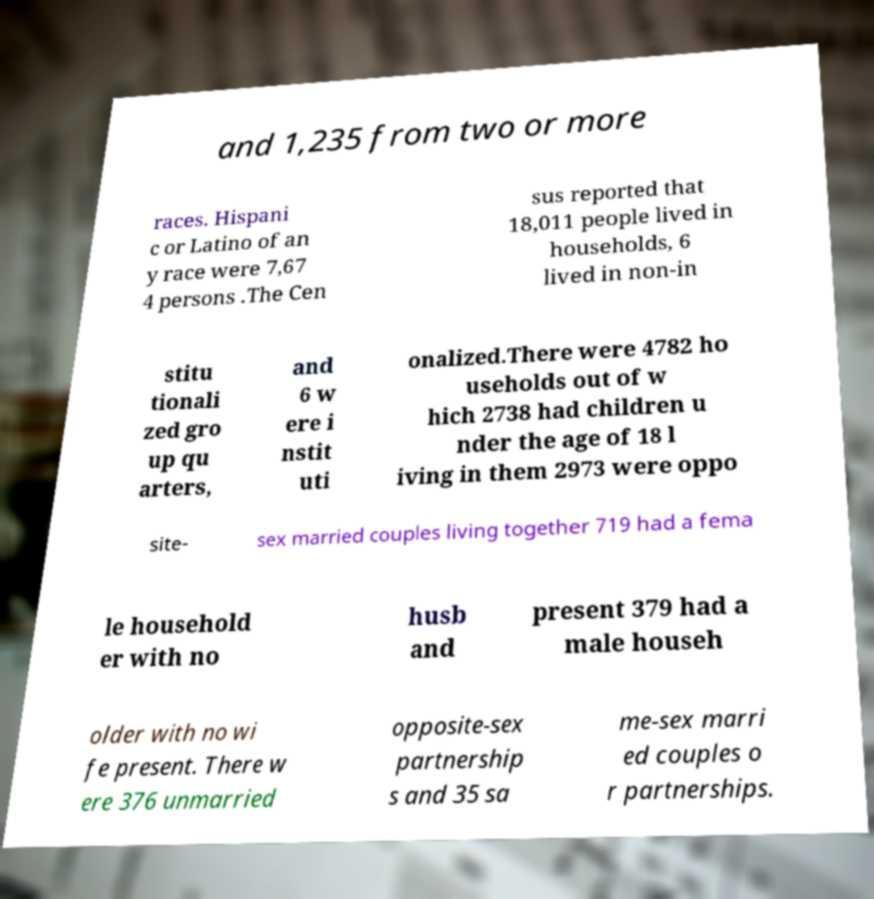Could you assist in decoding the text presented in this image and type it out clearly? and 1,235 from two or more races. Hispani c or Latino of an y race were 7,67 4 persons .The Cen sus reported that 18,011 people lived in households, 6 lived in non-in stitu tionali zed gro up qu arters, and 6 w ere i nstit uti onalized.There were 4782 ho useholds out of w hich 2738 had children u nder the age of 18 l iving in them 2973 were oppo site- sex married couples living together 719 had a fema le household er with no husb and present 379 had a male househ older with no wi fe present. There w ere 376 unmarried opposite-sex partnership s and 35 sa me-sex marri ed couples o r partnerships. 